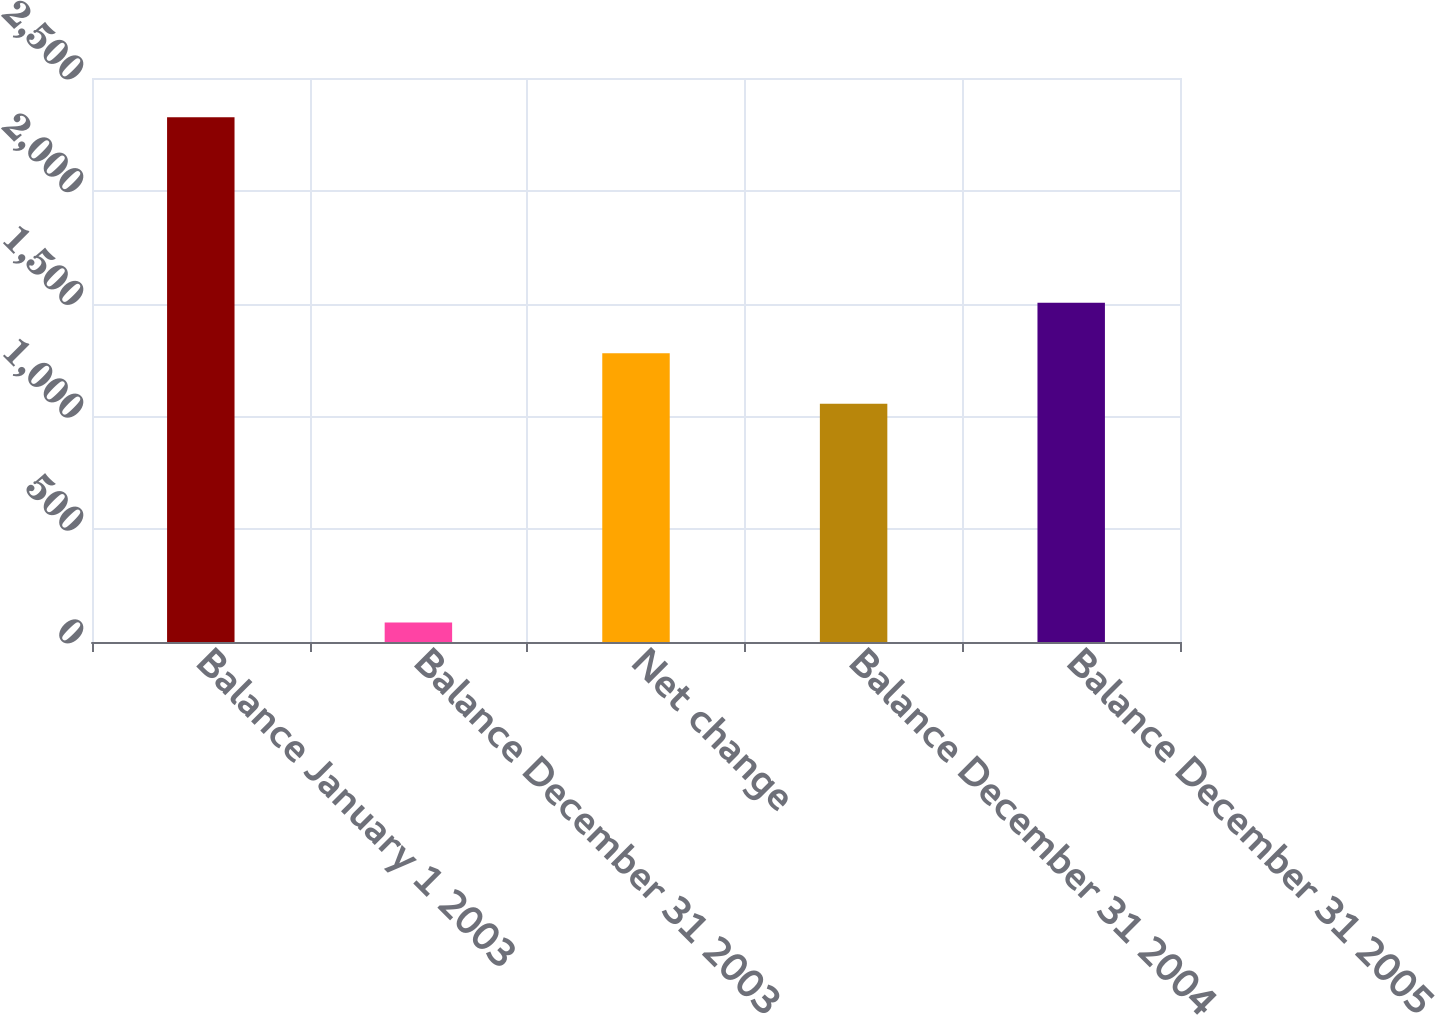<chart> <loc_0><loc_0><loc_500><loc_500><bar_chart><fcel>Balance January 1 2003<fcel>Balance December 31 2003<fcel>Net change<fcel>Balance December 31 2004<fcel>Balance December 31 2005<nl><fcel>2326<fcel>86<fcel>1280<fcel>1056<fcel>1504<nl></chart> 